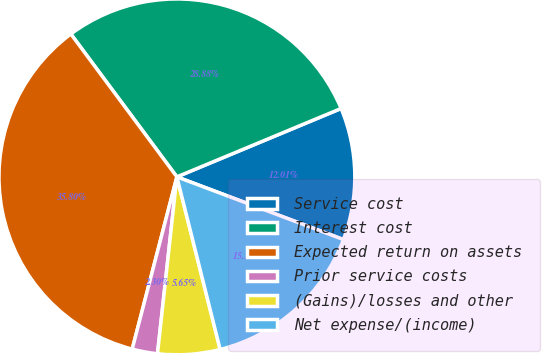<chart> <loc_0><loc_0><loc_500><loc_500><pie_chart><fcel>Service cost<fcel>Interest cost<fcel>Expected return on assets<fcel>Prior service costs<fcel>(Gains)/losses and other<fcel>Net expense/(income)<nl><fcel>12.01%<fcel>28.88%<fcel>35.8%<fcel>2.3%<fcel>5.65%<fcel>15.36%<nl></chart> 